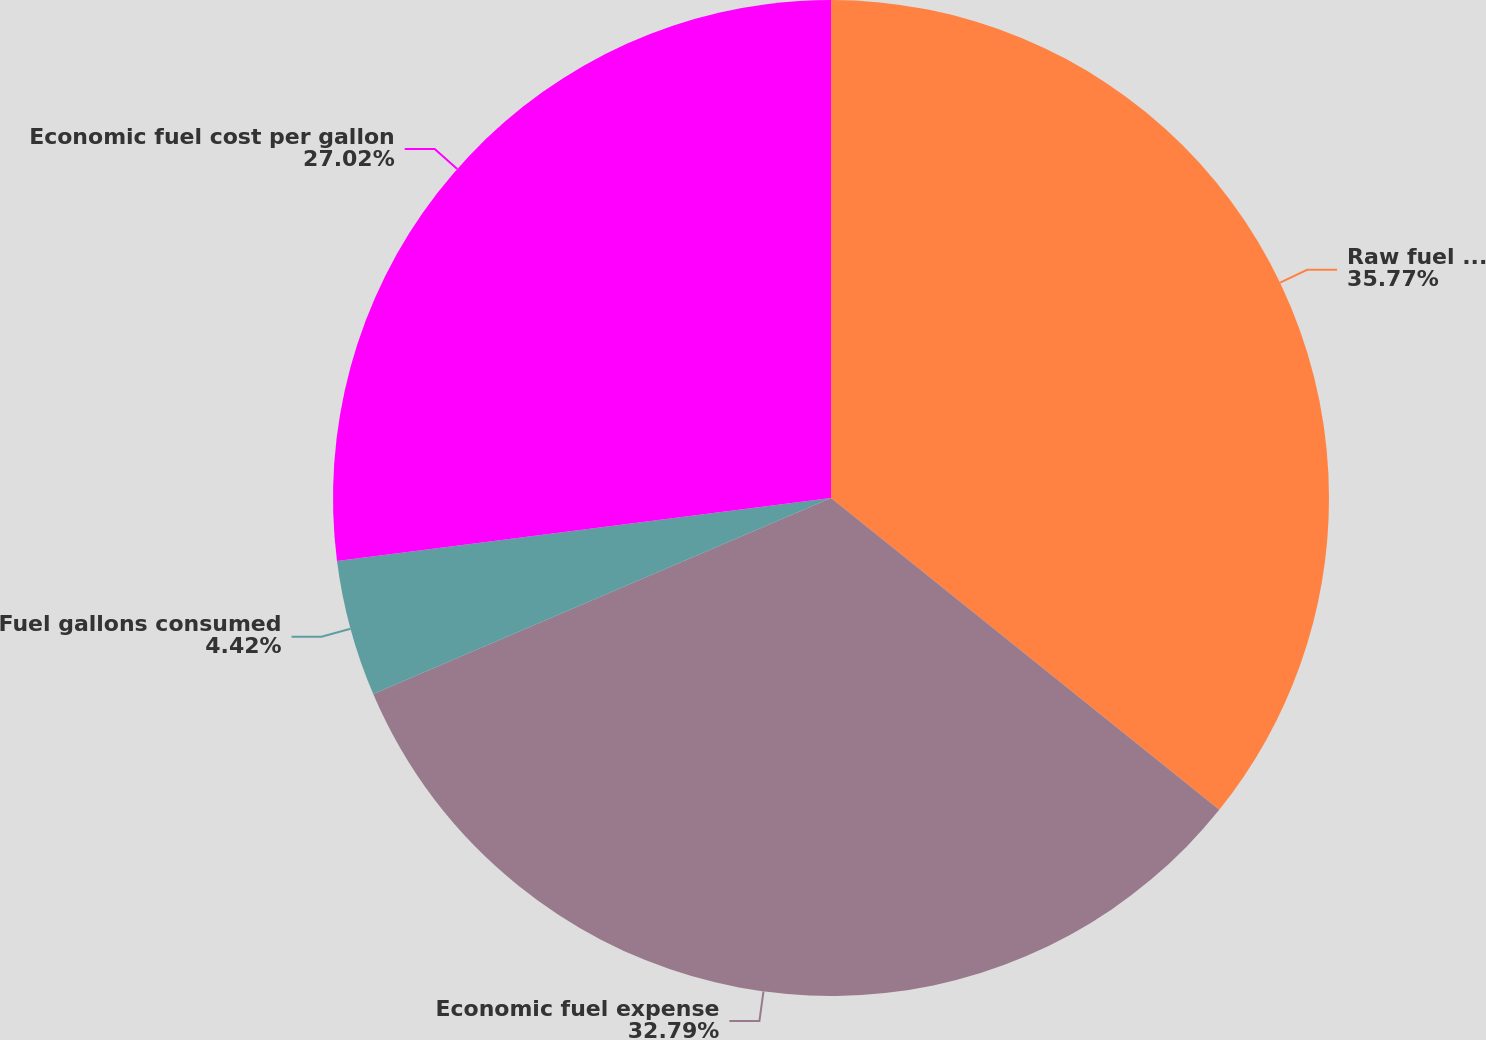Convert chart. <chart><loc_0><loc_0><loc_500><loc_500><pie_chart><fcel>Raw fuel expense<fcel>Economic fuel expense<fcel>Fuel gallons consumed<fcel>Economic fuel cost per gallon<nl><fcel>35.77%<fcel>32.79%<fcel>4.42%<fcel>27.02%<nl></chart> 